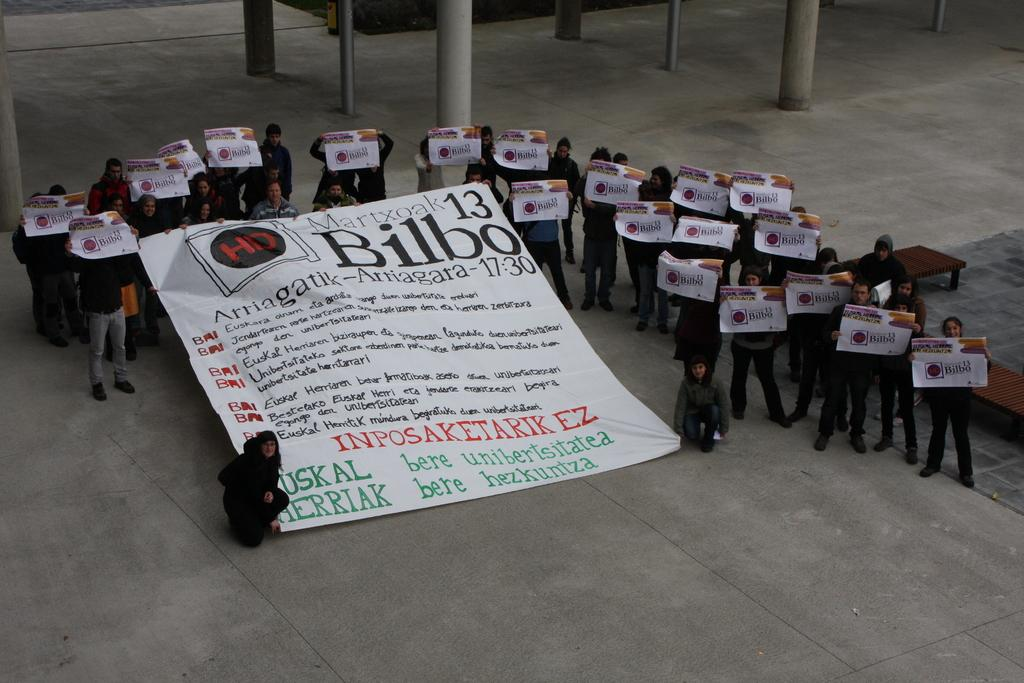What is the main object in the middle of the image? There is a big banner in the middle of the image. What else can be seen in the image besides the banner? There is a group of people in the image. What are the people holding in their hands? The people are holding placards. What is the caption written on the banner in the image? There is no caption visible on the banner in the image; only the banner itself is mentioned. 